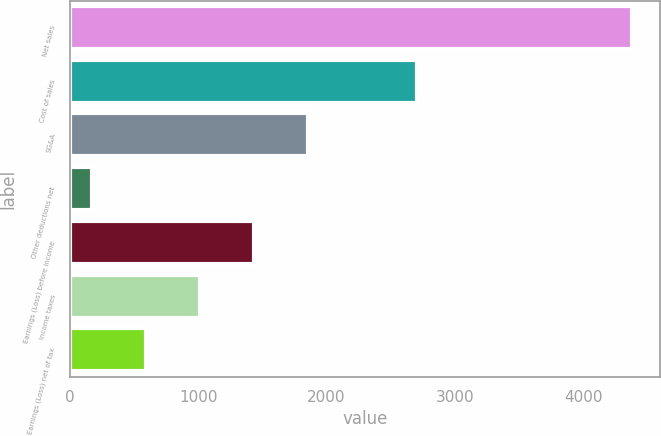Convert chart. <chart><loc_0><loc_0><loc_500><loc_500><bar_chart><fcel>Net sales<fcel>Cost of sales<fcel>SG&A<fcel>Other deductions net<fcel>Earnings (Loss) before income<fcel>Income taxes<fcel>Earnings (Loss) net of tax<nl><fcel>4378<fcel>2708<fcel>1854.4<fcel>172<fcel>1433.8<fcel>1013.2<fcel>592.6<nl></chart> 